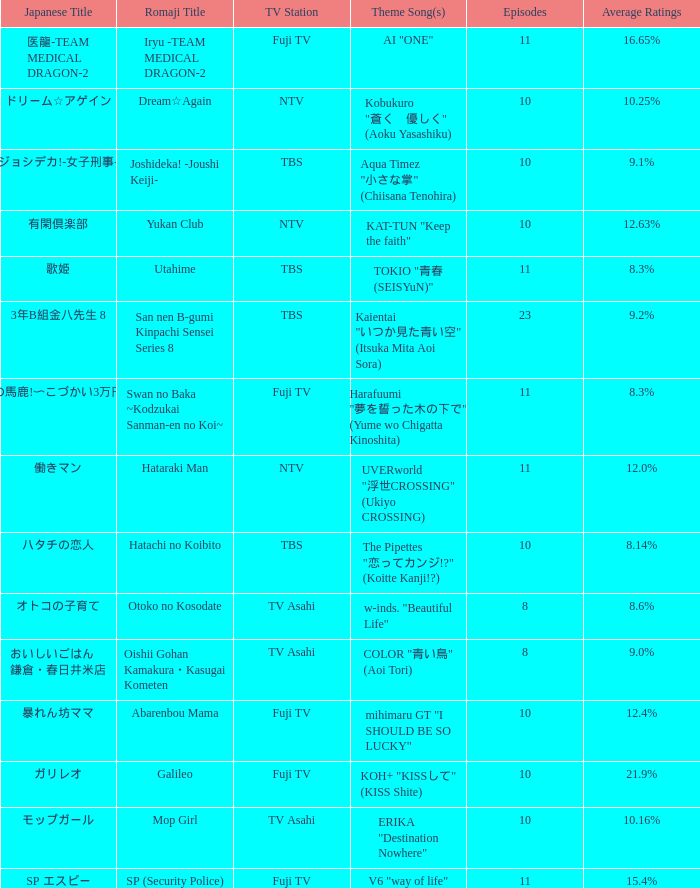What is the Theme Song of the show on Fuji TV Station with Average Ratings of 16.65%? AI "ONE". 